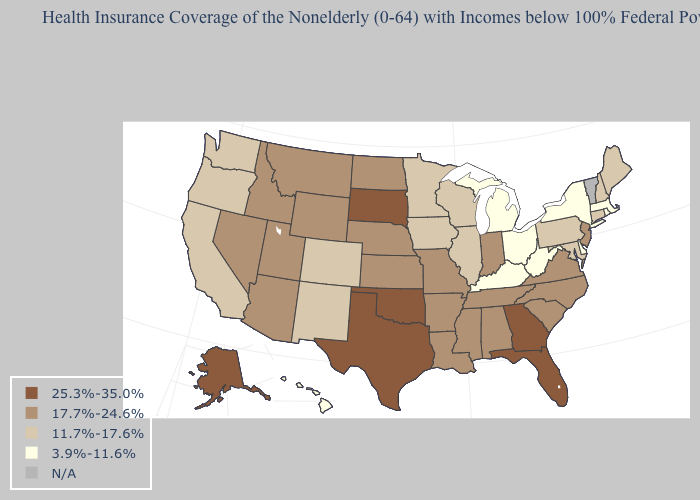What is the highest value in the West ?
Write a very short answer. 25.3%-35.0%. Which states hav the highest value in the South?
Keep it brief. Florida, Georgia, Oklahoma, Texas. Does the first symbol in the legend represent the smallest category?
Concise answer only. No. Is the legend a continuous bar?
Keep it brief. No. Name the states that have a value in the range N/A?
Give a very brief answer. Vermont. What is the value of Maryland?
Answer briefly. 11.7%-17.6%. How many symbols are there in the legend?
Keep it brief. 5. What is the highest value in the USA?
Short answer required. 25.3%-35.0%. Name the states that have a value in the range 11.7%-17.6%?
Quick response, please. California, Colorado, Connecticut, Illinois, Iowa, Maine, Maryland, Minnesota, New Hampshire, New Mexico, Oregon, Pennsylvania, Washington, Wisconsin. What is the value of Oregon?
Keep it brief. 11.7%-17.6%. Which states have the highest value in the USA?
Quick response, please. Alaska, Florida, Georgia, Oklahoma, South Dakota, Texas. What is the value of New York?
Answer briefly. 3.9%-11.6%. What is the value of Wyoming?
Write a very short answer. 17.7%-24.6%. 